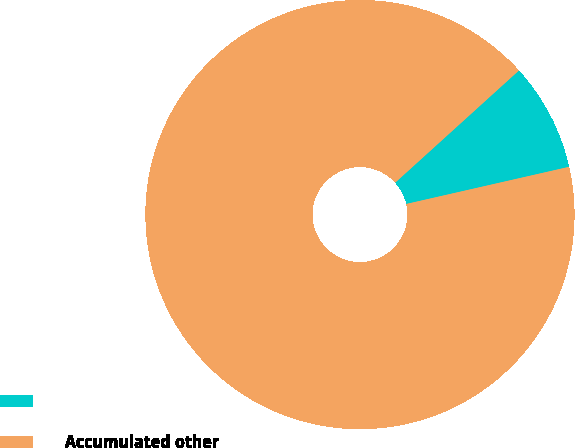Convert chart. <chart><loc_0><loc_0><loc_500><loc_500><pie_chart><ecel><fcel>Accumulated other<nl><fcel>8.15%<fcel>91.85%<nl></chart> 